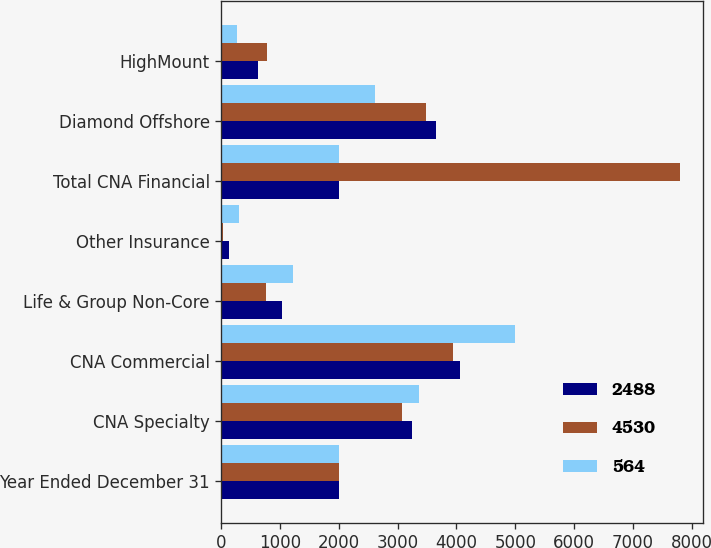Convert chart. <chart><loc_0><loc_0><loc_500><loc_500><stacked_bar_chart><ecel><fcel>Year Ended December 31<fcel>CNA Specialty<fcel>CNA Commercial<fcel>Life & Group Non-Core<fcel>Other Insurance<fcel>Total CNA Financial<fcel>Diamond Offshore<fcel>HighMount<nl><fcel>2488<fcel>2009<fcel>3242<fcel>4061<fcel>1035<fcel>134<fcel>2008.5<fcel>3653<fcel>620<nl><fcel>4530<fcel>2008<fcel>3071<fcel>3937<fcel>761<fcel>30<fcel>7799<fcel>3486<fcel>770<nl><fcel>564<fcel>2007<fcel>3368<fcel>4999<fcel>1220<fcel>299<fcel>2008.5<fcel>2617<fcel>274<nl></chart> 